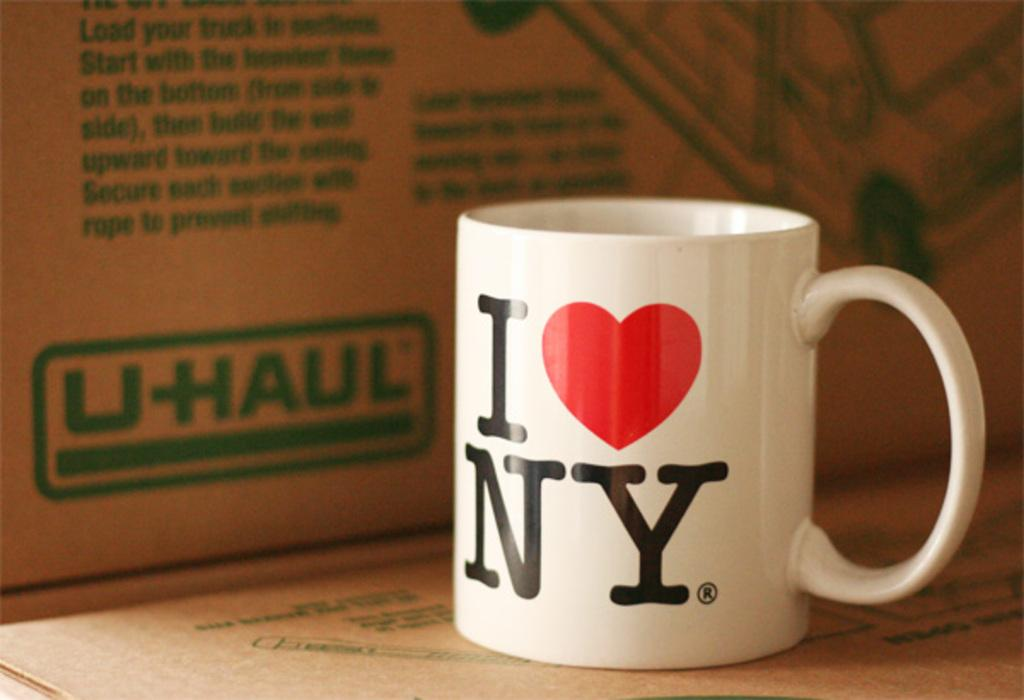Provide a one-sentence caption for the provided image. A white coffee cup that say I with a picture of a heart Ny next to a Uhaul box. 